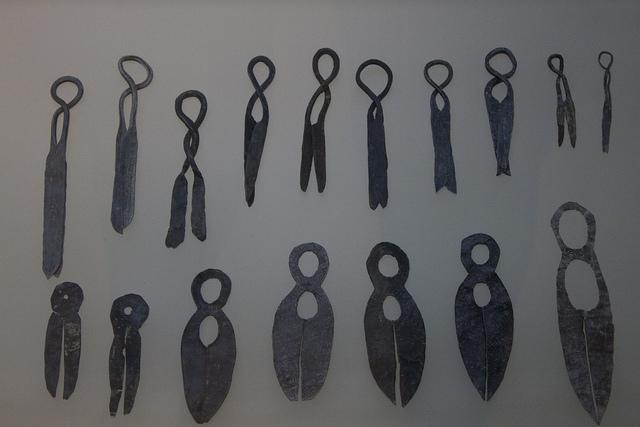How many items are on the wall?
Write a very short answer. 17. What are the objects displayed?
Answer briefly. Scissors. How many scissors are shown?
Give a very brief answer. 17. What color are the items on the wall?
Quick response, please. Black. What type of items are these?
Answer briefly. Scissors. 